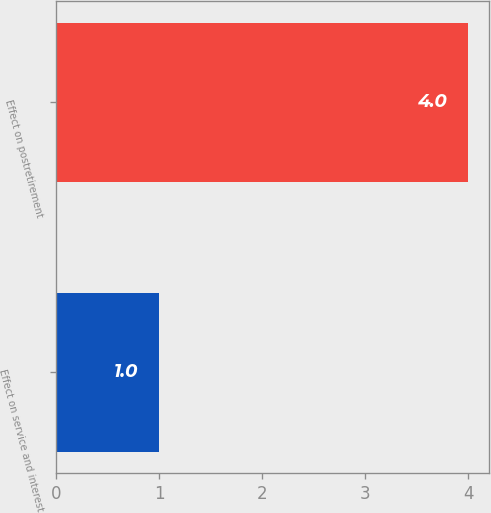Convert chart. <chart><loc_0><loc_0><loc_500><loc_500><bar_chart><fcel>Effect on service and interest<fcel>Effect on postretirement<nl><fcel>1<fcel>4<nl></chart> 